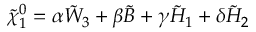Convert formula to latex. <formula><loc_0><loc_0><loc_500><loc_500>\tilde { \chi } _ { 1 } ^ { 0 } = \alpha \tilde { W } _ { 3 } + \beta \tilde { B } + \gamma \tilde { H } _ { 1 } + \delta \tilde { H } _ { 2 }</formula> 